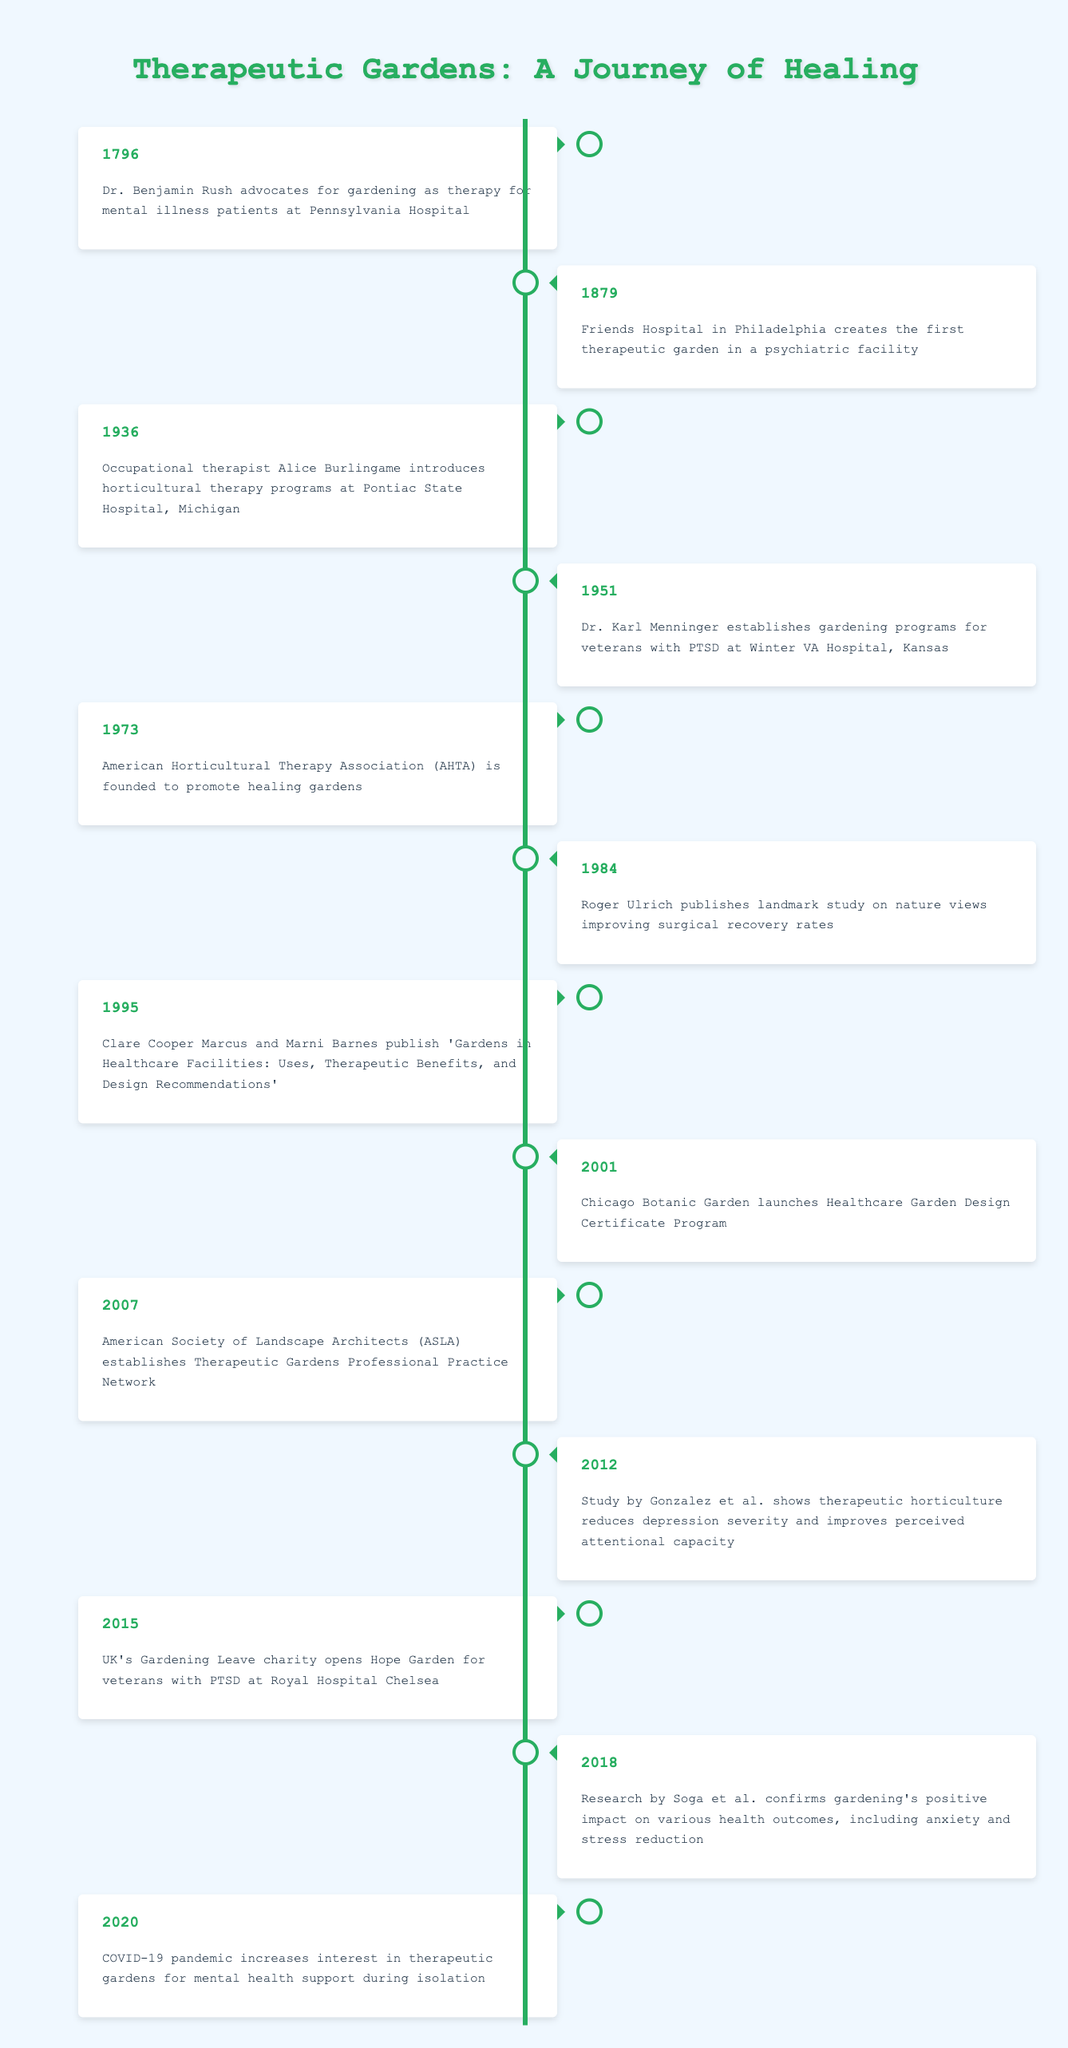What year did Dr. Benjamin Rush advocate for gardening as therapy? The timeline shows that Dr. Benjamin Rush advocated for gardening as therapy in the year 1796.
Answer: 1796 What significant event occurred in 1973 regarding therapeutic gardens? In 1973, the American Horticultural Therapy Association was founded to promote healing gardens.
Answer: AHTA was founded How many years passed between the establishment of the first therapeutic garden and the publication of the landmark study by Roger Ulrich? The first therapeutic garden was established in 1879, and Roger Ulrich published his study in 1984. The difference is 1984 - 1879 = 5 years.
Answer: 5 years Did Dr. Karl Menninger establish gardening programs for veterans before 1960? According to the timeline, Dr. Karl Menninger established gardening programs in 1951, which is before 1960.
Answer: Yes What was the focus of the 2012 study by Gonzalez et al.? The study by Gonzalez et al. in 2012 focused on therapeutic horticulture, showing it reduces depression severity and improves perceived attentional capacity.
Answer: Reduces depression and improves attention How many events are listed in the timeline between 1950 and 2000? From 1951 to 2001, the events include Dr. Menninger's establishment in 1951, AHTA in 1973, publishing of the book in 1995, and setting up the program in 2001, totaling 4 events.
Answer: 4 events Was there any research confirming the benefits of gardening on health outcomes in 2018? Yes, the research by Soga et al. in 2018 confirmed gardening's positive impact on various health outcomes, including anxiety and stress reduction.
Answer: Yes What major global event increased interest in therapeutic gardens in 2020? The COVID-19 pandemic increased the interest in therapeutic gardens for mental health support during isolation.
Answer: COVID-19 pandemic How has the timeline of therapeutic gardens evolved in terms of recognized organizations from 1973? After the AHTA was founded in 1973, there were several notable events including the establishment of professional networks like ASLA in 2007, showing growth in the recognition and structuring of therapeutic gardens.
Answer: Increased organization recognition 